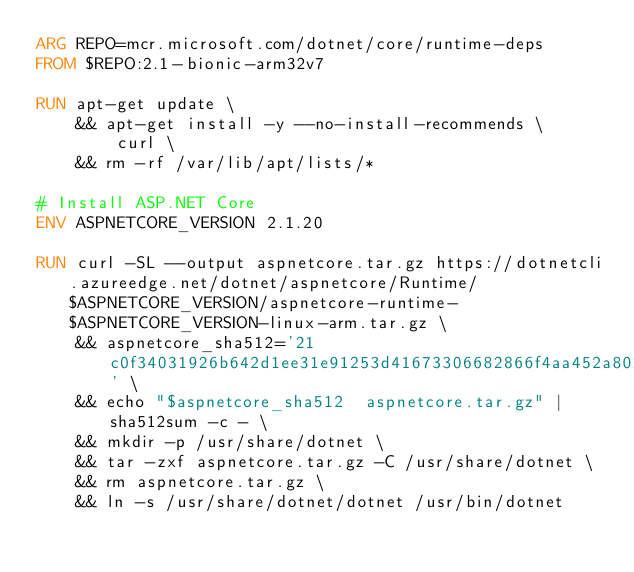Convert code to text. <code><loc_0><loc_0><loc_500><loc_500><_Dockerfile_>ARG REPO=mcr.microsoft.com/dotnet/core/runtime-deps
FROM $REPO:2.1-bionic-arm32v7

RUN apt-get update \
    && apt-get install -y --no-install-recommends \
        curl \
    && rm -rf /var/lib/apt/lists/*

# Install ASP.NET Core
ENV ASPNETCORE_VERSION 2.1.20

RUN curl -SL --output aspnetcore.tar.gz https://dotnetcli.azureedge.net/dotnet/aspnetcore/Runtime/$ASPNETCORE_VERSION/aspnetcore-runtime-$ASPNETCORE_VERSION-linux-arm.tar.gz \
    && aspnetcore_sha512='21c0f34031926b642d1ee31e91253d41673306682866f4aa452a802292df425056311fe315bec2f0681a92d71cf5f799f2f17b29994c1299660b8add78dab68e' \
    && echo "$aspnetcore_sha512  aspnetcore.tar.gz" | sha512sum -c - \
    && mkdir -p /usr/share/dotnet \
    && tar -zxf aspnetcore.tar.gz -C /usr/share/dotnet \
    && rm aspnetcore.tar.gz \
    && ln -s /usr/share/dotnet/dotnet /usr/bin/dotnet
</code> 